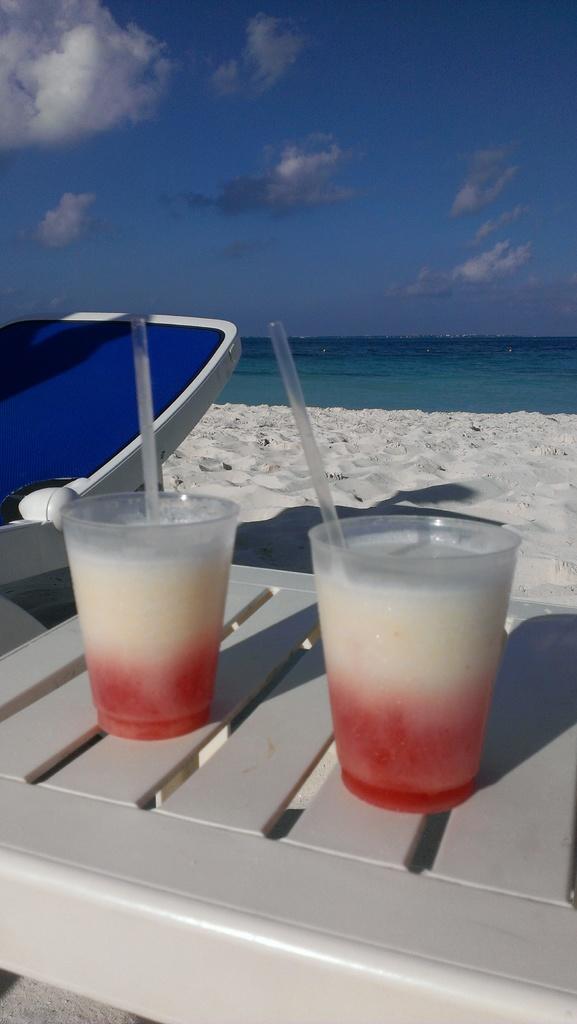How would you summarize this image in a sentence or two? In this image we can see the two glasses with straws on the surface. And we can see the rest chair. And we can see the sand and the water. And we can see the clouds in the sky. 